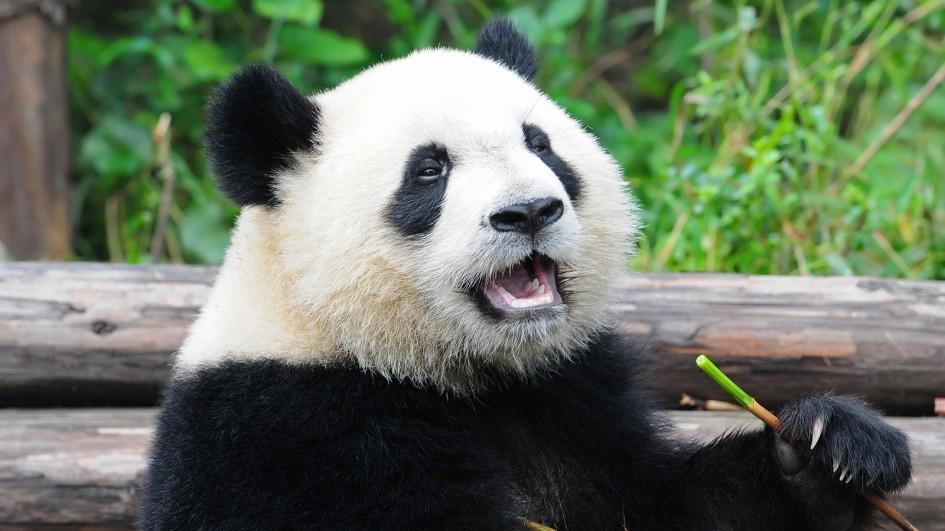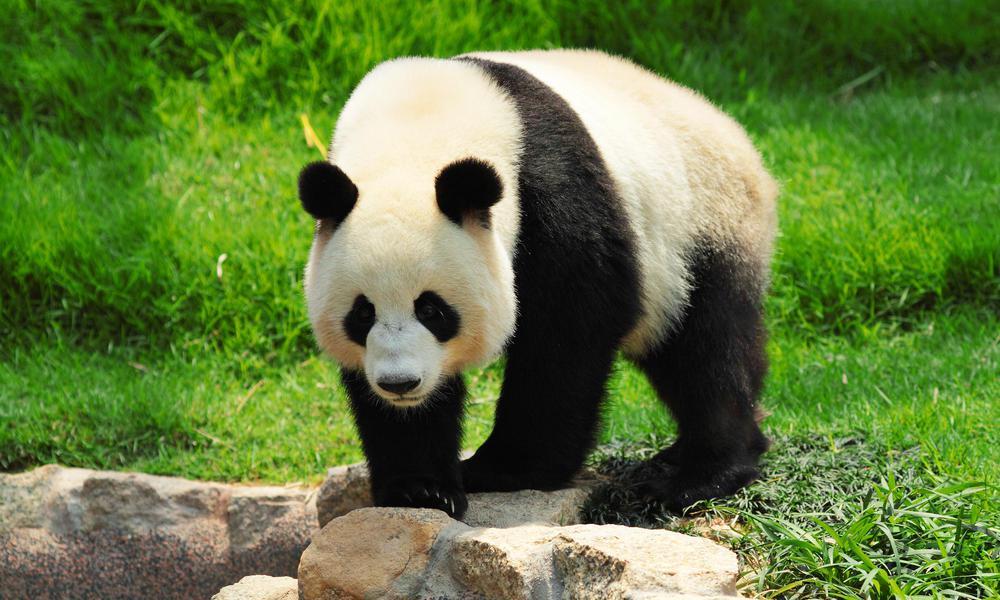The first image is the image on the left, the second image is the image on the right. Examine the images to the left and right. Is the description "the panda on the left image has its mouth open" accurate? Answer yes or no. Yes. 